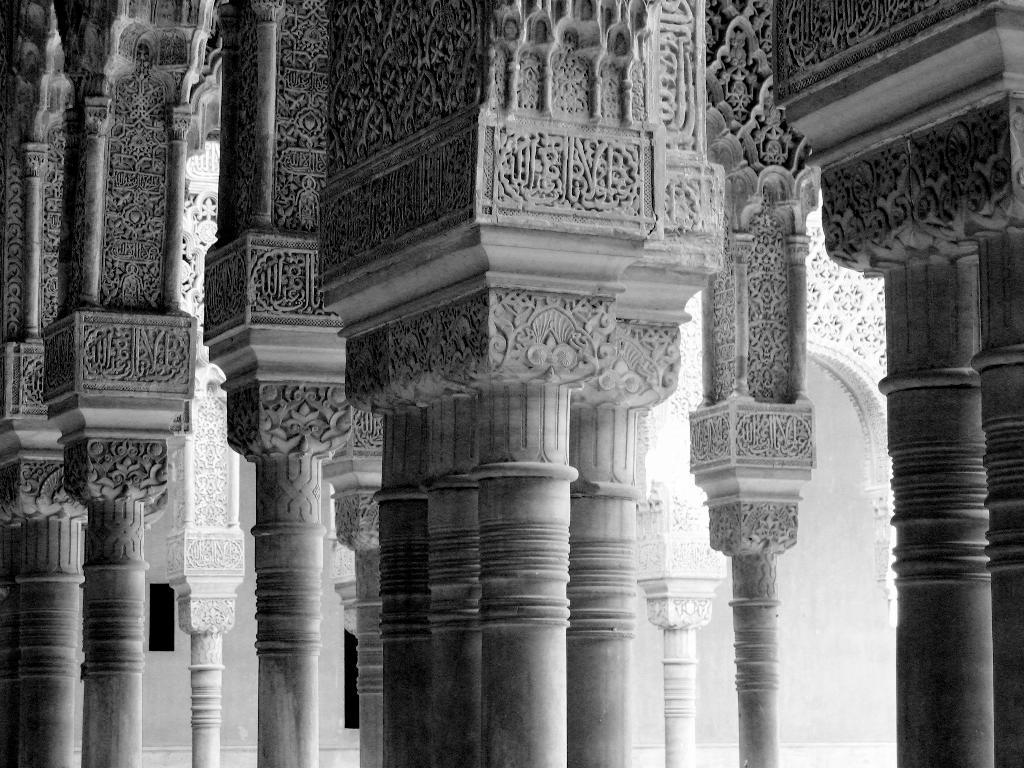How would you summarize this image in a sentence or two? In this picture I can see the pillars, this image is in black and white color, it looks like a monument. 